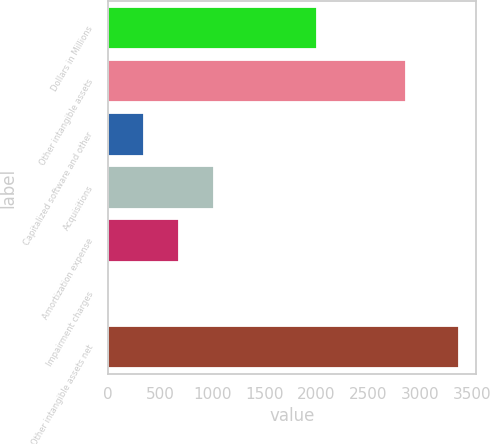Convert chart. <chart><loc_0><loc_0><loc_500><loc_500><bar_chart><fcel>Dollars in Millions<fcel>Other intangible assets<fcel>Capitalized software and other<fcel>Acquisitions<fcel>Amortization expense<fcel>Impairment charges<fcel>Other intangible assets net<nl><fcel>2010<fcel>2865<fcel>346<fcel>1018<fcel>682<fcel>10<fcel>3370<nl></chart> 